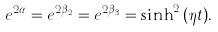<formula> <loc_0><loc_0><loc_500><loc_500>e ^ { 2 \alpha } = e ^ { 2 \beta _ { 2 } } = e ^ { 2 \beta _ { 3 } } = \sinh ^ { 2 } { ( \eta t ) } .</formula> 